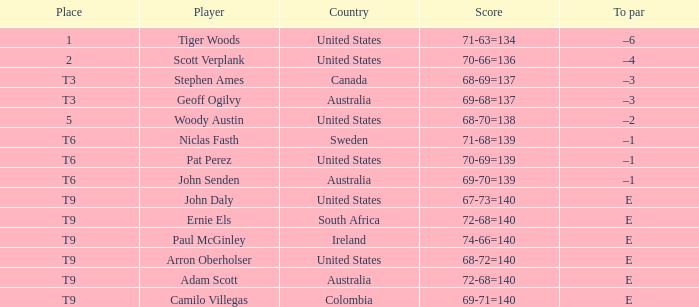Which player has a to par of e and a score of 67-73=140? John Daly. 